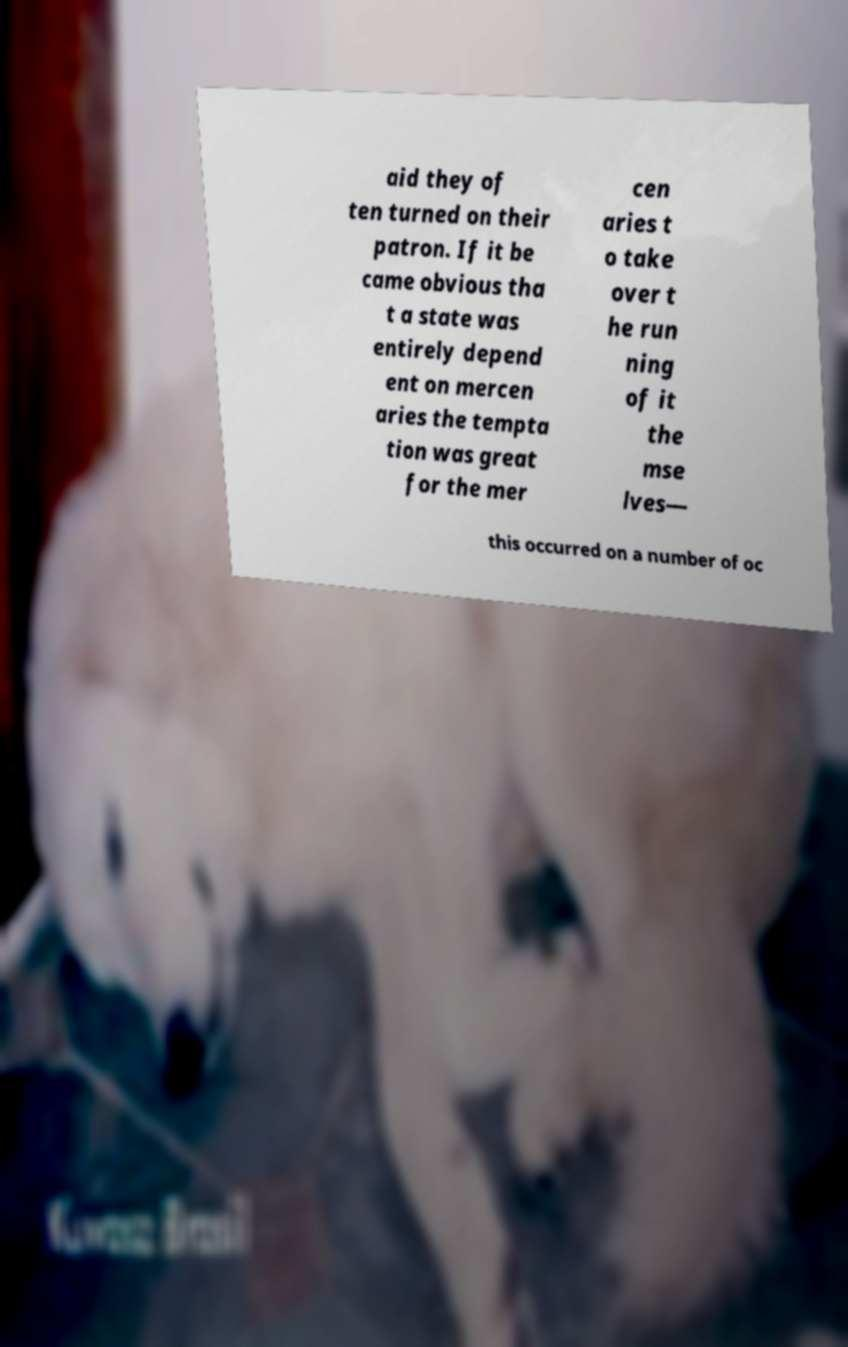I need the written content from this picture converted into text. Can you do that? aid they of ten turned on their patron. If it be came obvious tha t a state was entirely depend ent on mercen aries the tempta tion was great for the mer cen aries t o take over t he run ning of it the mse lves— this occurred on a number of oc 